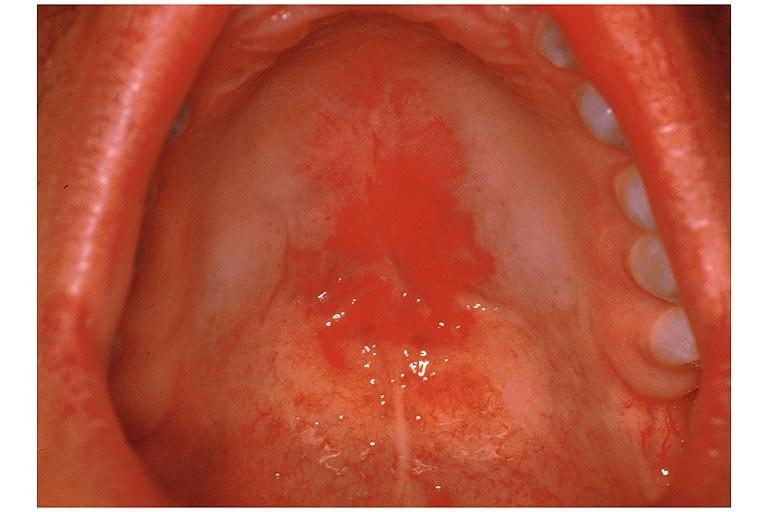what does this image show?
Answer the question using a single word or phrase. Candidiasis-erythematous 